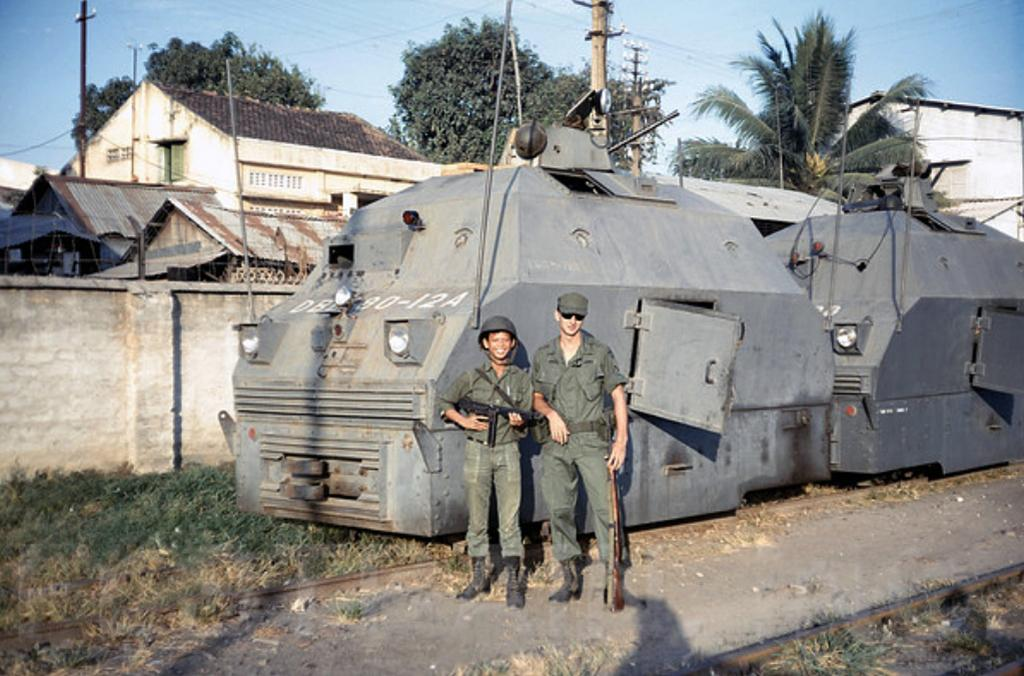How many men are in the image? There are two men standing in the image. What are the men holding in the image? The men are holding guns. What type of vehicles can be seen in the image? There are railcars in the image. What type of vegetation is present in the image? Grass is present in the image. What type of structure can be seen in the image? There is a wall in the image. What type of support structures are visible in the image? Poles are visible in the image. What type of buildings can be seen in the image? There are houses in the image. What type of infrastructure is present in the image? Wires are present in the image. What can be seen in the background of the image? There are trees and the sky visible in the background of the image. What type of glass is used to make the pear in the image? There is no glass or pear present in the image. What type of brick is used to construct the houses in the image? The provided facts do not mention the type of brick used to construct the houses in the image. 